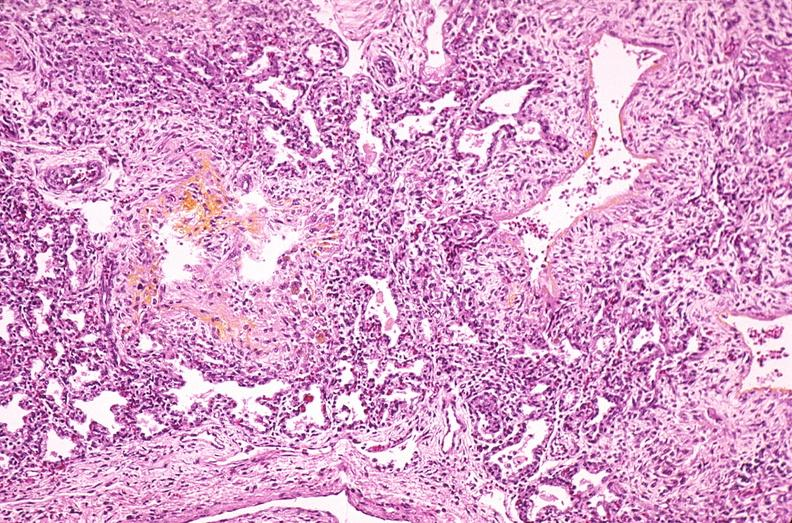does this image show lung, hyaline membrane disease, yellow discoloration due to hyperbilirubinemia?
Answer the question using a single word or phrase. Yes 